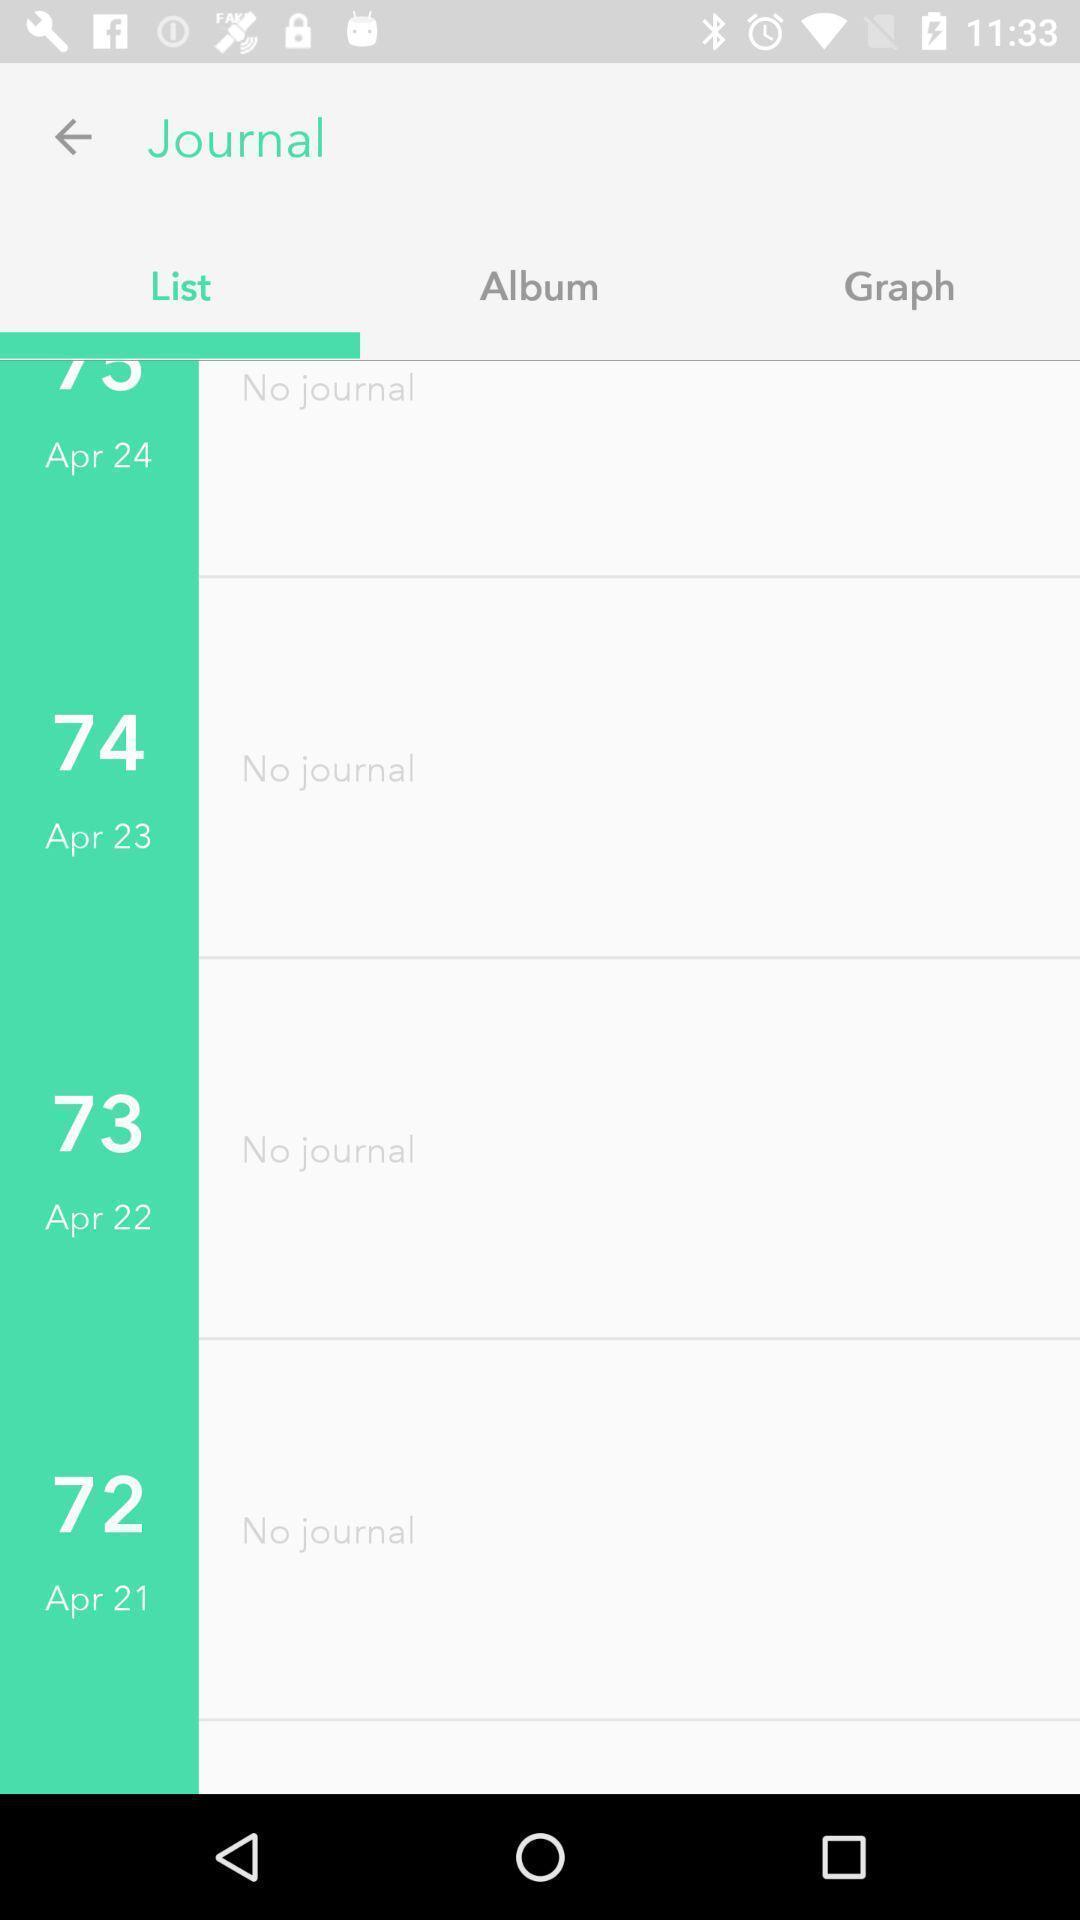Describe the key features of this screenshot. Screen showing no journal. 